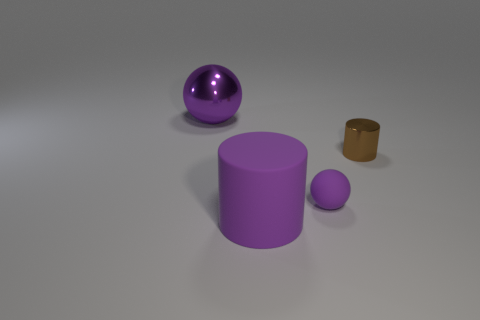How many other objects are there of the same size as the brown cylinder?
Give a very brief answer. 1. How many cylinders are big yellow rubber objects or tiny brown shiny things?
Provide a succinct answer. 1. Is there any other thing that is the same material as the small brown object?
Offer a terse response. Yes. The cylinder behind the purple sphere right of the big purple object that is to the left of the large matte cylinder is made of what material?
Your response must be concise. Metal. What is the material of the small thing that is the same color as the large matte cylinder?
Ensure brevity in your answer.  Rubber. How many big purple balls are the same material as the small cylinder?
Ensure brevity in your answer.  1. There is a purple ball that is left of the purple rubber cylinder; is its size the same as the small matte object?
Keep it short and to the point. No. The large ball that is made of the same material as the small brown thing is what color?
Provide a short and direct response. Purple. What number of purple spheres are right of the tiny brown thing?
Offer a terse response. 0. There is a big sphere that is behind the brown object; is its color the same as the ball that is in front of the metal cylinder?
Ensure brevity in your answer.  Yes. 